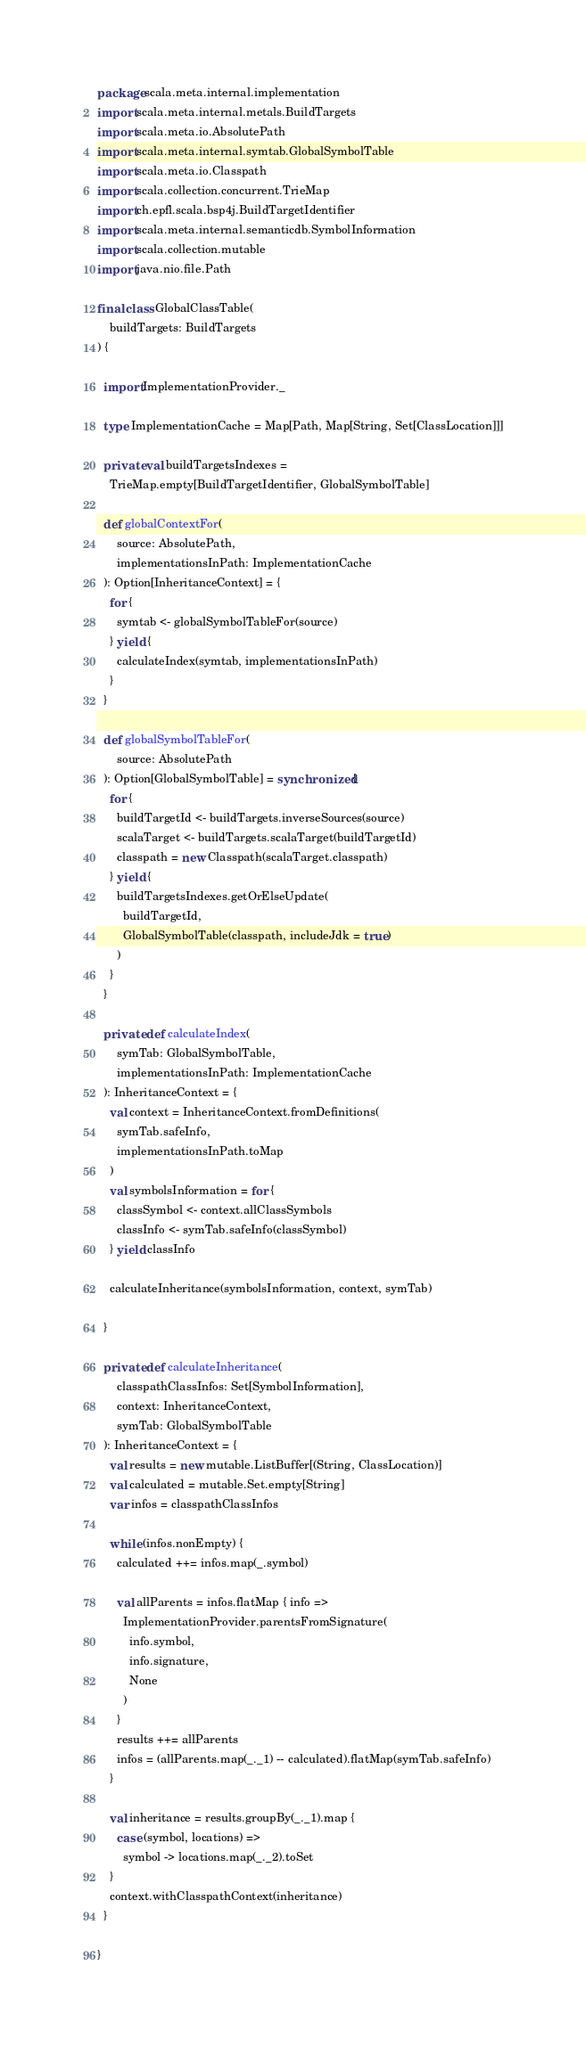Convert code to text. <code><loc_0><loc_0><loc_500><loc_500><_Scala_>package scala.meta.internal.implementation
import scala.meta.internal.metals.BuildTargets
import scala.meta.io.AbsolutePath
import scala.meta.internal.symtab.GlobalSymbolTable
import scala.meta.io.Classpath
import scala.collection.concurrent.TrieMap
import ch.epfl.scala.bsp4j.BuildTargetIdentifier
import scala.meta.internal.semanticdb.SymbolInformation
import scala.collection.mutable
import java.nio.file.Path

final class GlobalClassTable(
    buildTargets: BuildTargets
) {

  import ImplementationProvider._

  type ImplementationCache = Map[Path, Map[String, Set[ClassLocation]]]

  private val buildTargetsIndexes =
    TrieMap.empty[BuildTargetIdentifier, GlobalSymbolTable]

  def globalContextFor(
      source: AbsolutePath,
      implementationsInPath: ImplementationCache
  ): Option[InheritanceContext] = {
    for {
      symtab <- globalSymbolTableFor(source)
    } yield {
      calculateIndex(symtab, implementationsInPath)
    }
  }

  def globalSymbolTableFor(
      source: AbsolutePath
  ): Option[GlobalSymbolTable] = synchronized {
    for {
      buildTargetId <- buildTargets.inverseSources(source)
      scalaTarget <- buildTargets.scalaTarget(buildTargetId)
      classpath = new Classpath(scalaTarget.classpath)
    } yield {
      buildTargetsIndexes.getOrElseUpdate(
        buildTargetId,
        GlobalSymbolTable(classpath, includeJdk = true)
      )
    }
  }

  private def calculateIndex(
      symTab: GlobalSymbolTable,
      implementationsInPath: ImplementationCache
  ): InheritanceContext = {
    val context = InheritanceContext.fromDefinitions(
      symTab.safeInfo,
      implementationsInPath.toMap
    )
    val symbolsInformation = for {
      classSymbol <- context.allClassSymbols
      classInfo <- symTab.safeInfo(classSymbol)
    } yield classInfo

    calculateInheritance(symbolsInformation, context, symTab)

  }

  private def calculateInheritance(
      classpathClassInfos: Set[SymbolInformation],
      context: InheritanceContext,
      symTab: GlobalSymbolTable
  ): InheritanceContext = {
    val results = new mutable.ListBuffer[(String, ClassLocation)]
    val calculated = mutable.Set.empty[String]
    var infos = classpathClassInfos

    while (infos.nonEmpty) {
      calculated ++= infos.map(_.symbol)

      val allParents = infos.flatMap { info =>
        ImplementationProvider.parentsFromSignature(
          info.symbol,
          info.signature,
          None
        )
      }
      results ++= allParents
      infos = (allParents.map(_._1) -- calculated).flatMap(symTab.safeInfo)
    }

    val inheritance = results.groupBy(_._1).map {
      case (symbol, locations) =>
        symbol -> locations.map(_._2).toSet
    }
    context.withClasspathContext(inheritance)
  }

}
</code> 